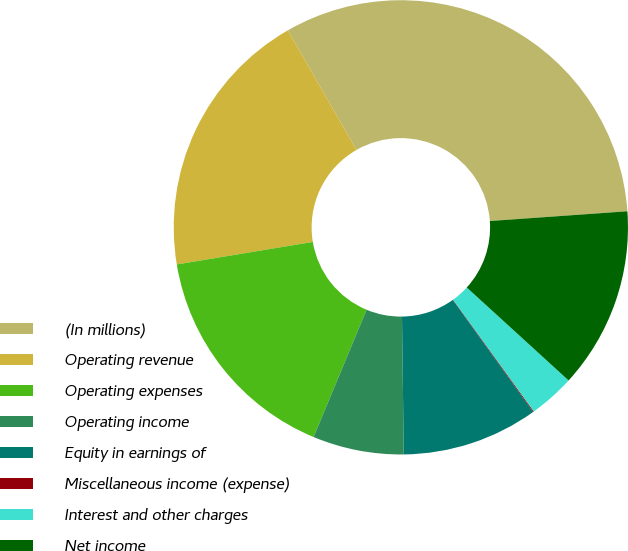Convert chart to OTSL. <chart><loc_0><loc_0><loc_500><loc_500><pie_chart><fcel>(In millions)<fcel>Operating revenue<fcel>Operating expenses<fcel>Operating income<fcel>Equity in earnings of<fcel>Miscellaneous income (expense)<fcel>Interest and other charges<fcel>Net income<nl><fcel>32.16%<fcel>19.32%<fcel>16.11%<fcel>6.48%<fcel>9.69%<fcel>0.06%<fcel>3.27%<fcel>12.9%<nl></chart> 